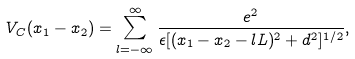Convert formula to latex. <formula><loc_0><loc_0><loc_500><loc_500>V _ { C } ( x _ { 1 } - x _ { 2 } ) = \sum _ { l = - \infty } ^ { \infty } \frac { e ^ { 2 } } { \epsilon [ ( x _ { 1 } - x _ { 2 } - l L ) ^ { 2 } + d ^ { 2 } ] ^ { 1 / 2 } } ,</formula> 